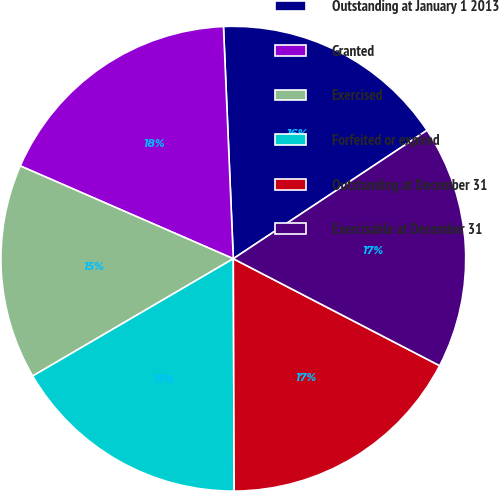<chart> <loc_0><loc_0><loc_500><loc_500><pie_chart><fcel>Outstanding at January 1 2013<fcel>Granted<fcel>Exercised<fcel>Forfeited or expired<fcel>Outstanding at December 31<fcel>Exercisable at December 31<nl><fcel>16.36%<fcel>17.79%<fcel>14.96%<fcel>16.64%<fcel>17.33%<fcel>16.93%<nl></chart> 